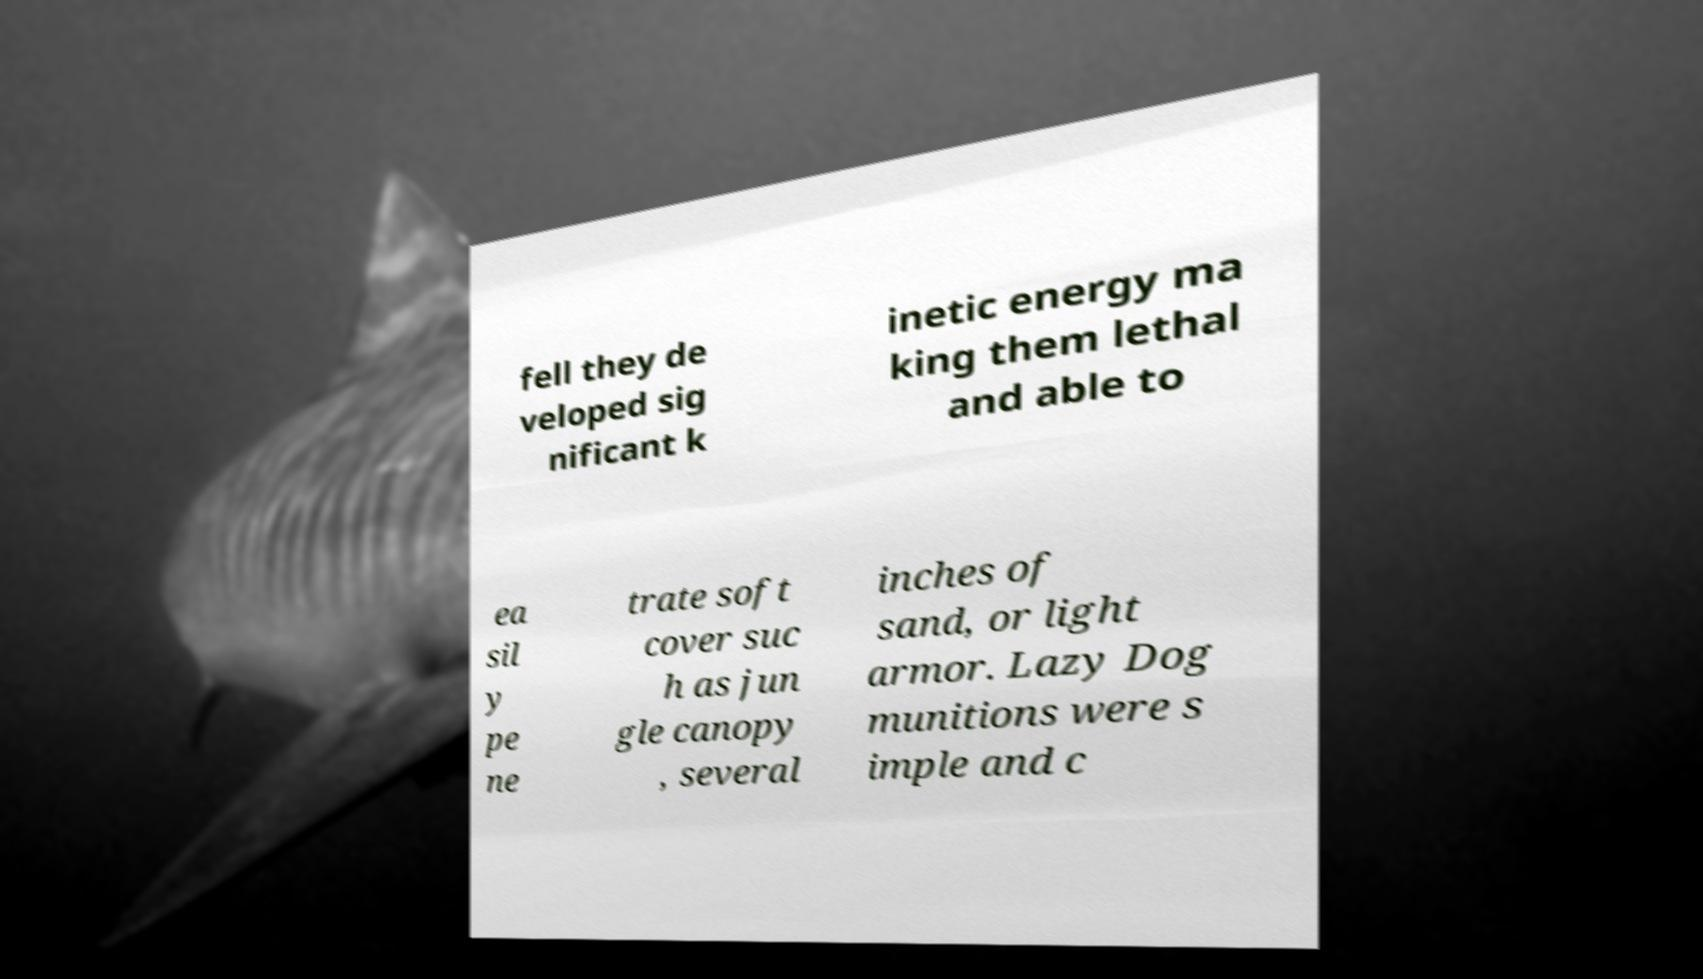Please identify and transcribe the text found in this image. fell they de veloped sig nificant k inetic energy ma king them lethal and able to ea sil y pe ne trate soft cover suc h as jun gle canopy , several inches of sand, or light armor. Lazy Dog munitions were s imple and c 